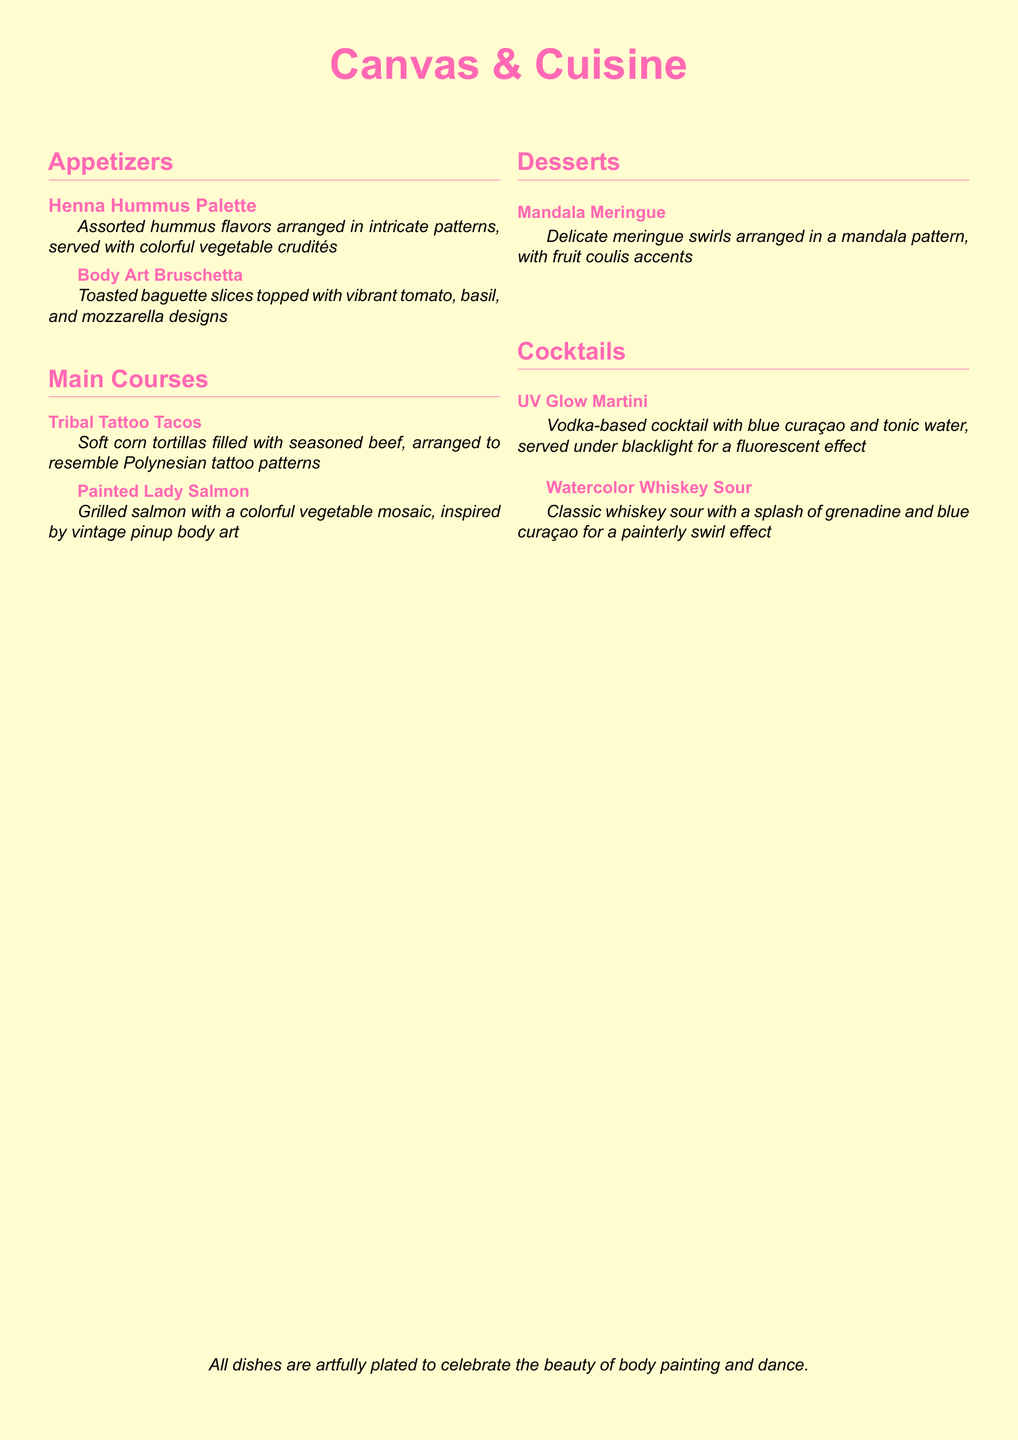What is the name of the restaurant? The title at the center of the menu indicates the name of the restaurant is "Canvas & Cuisine".
Answer: Canvas & Cuisine How many appetizers are listed on the menu? There are two appetizers mentioned in the appetizers section.
Answer: 2 What dish features a colorful vegetable mosaic? The dish "Painted Lady Salmon" is described as having a colorful vegetable mosaic.
Answer: Painted Lady Salmon Which cocktail is served under blacklight? The "UV Glow Martini" is specified to be served under blacklight for a fluorescent effect.
Answer: UV Glow Martini What is the description of the "Mandala Meringue"? The "Mandala Meringue" is described as delicate meringue swirls arranged in a mandala pattern, with fruit coulis accents.
Answer: Delicate meringue swirls arranged in a mandala pattern, with fruit coulis accents What type of dish is "Body Art Bruschetta"? It is an appetizer that includes toasted baguette slices topped with vibrant tomato, basil, and mozzarella designs.
Answer: Appetizer How many cocktails are on the menu? The cocktails section lists two different cocktails.
Answer: 2 What flavor of cocktail includes grenadine and blue curaçao? The "Watercolor Whiskey Sour" is the cocktail that includes a splash of grenadine and blue curaçao.
Answer: Watercolor Whiskey Sour 